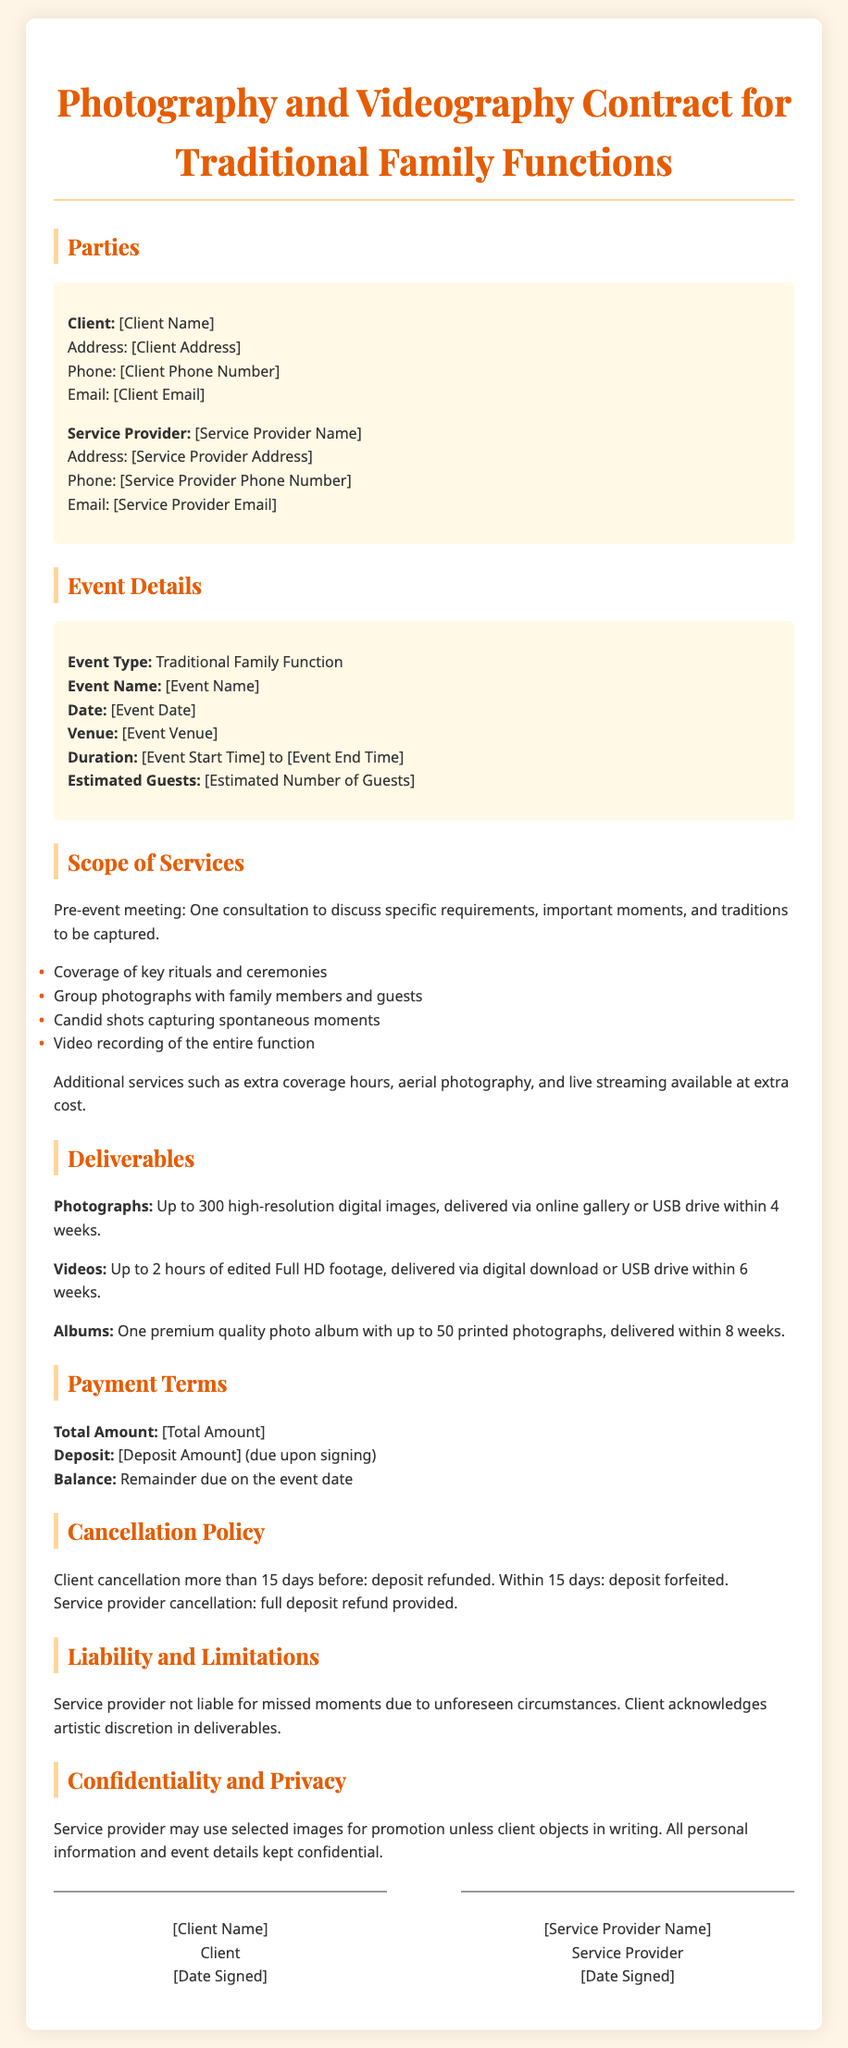What is the event type? The event type is specified in the document under event details, indicating the nature of the gathering.
Answer: Traditional Family Function What is the maximum number of photographs included? The document states the total number of photographs to be delivered as part of the services outlined.
Answer: Up to 300 What is the duration of the video footage delivered? The length of the edited video footage is specified under the deliverables section of the contract.
Answer: Up to 2 hours What is the cancellation policy if the client cancels within 15 days? The policy outlines the consequences of cancellation by the client within a specific timeframe regarding the deposit.
Answer: Deposit forfeited What is included in the deliverables? The document describes the main items that will be provided to the client after the event, summarizing the key deliverables.
Answer: Photographs, Videos, Albums What is the total amount due for the services? The total cost of the photography and videography services is mentioned in the payment terms section of the document.
Answer: [Total Amount] When is the deposit due? The document specifies the timing of the deposit payment related to the contract signing.
Answer: Upon signing Who is responsible for using images for promotion? The confidentiality section indicates which party has the right to use selected images unless there is an objection.
Answer: Service provider 